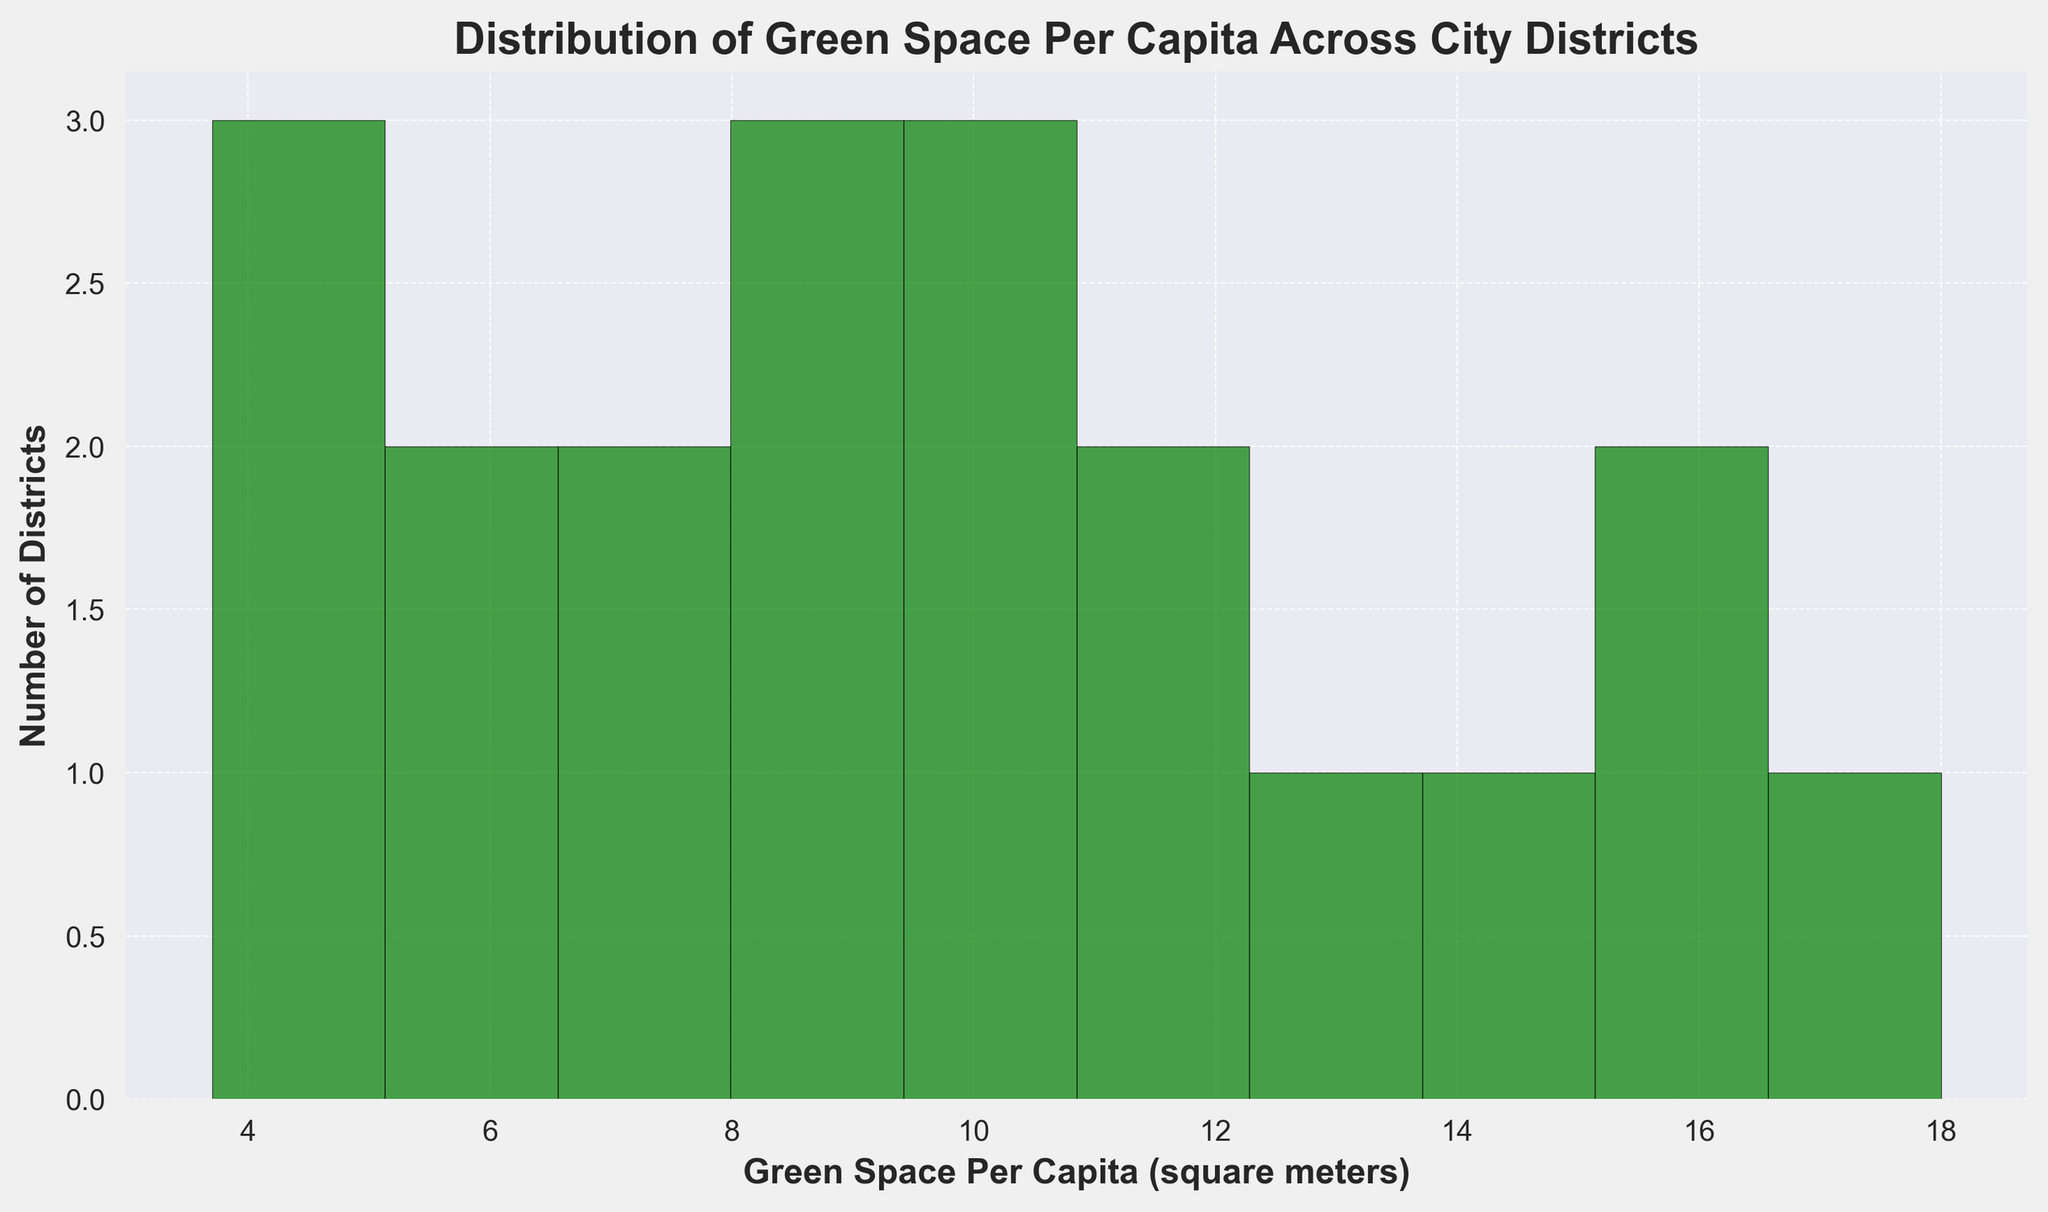Which green space per capita range has the highest number of districts? In the histogram, the green space per capita range represented by the tallest bar shows the highest number of districts.
Answer: 5-7 square meters Are there more districts with green space per capita less than 10 or more than 10? Count the number of districts with green space per capita on the left side of 10 (0-10) and on the right side of 10 (10-20) in the histogram. There are more bars to the right.
Answer: More than 10 What is the total number of districts represented in the histogram? By summing the heights of all bars in the histogram, you can determine the total number of districts.
Answer: 20 Compare the number of districts with green space per capita between 3 and 6 square meters to those between 12 and 15 square meters. Which range has more districts? Count the bars that fall within 3-6 and 12-15 square meters ranges. The 3-6 range has more districts than the 12-15 range.
Answer: 3-6 square meters What's the average green space per capita for districts with more than 10 square meters? Identify the bars with midpoints greater than 10, sum their midpoints, then divide by the number of such bars. (12+14+16+18)/4 = 15
Answer: 15 What's the ratio of the number of districts in the 8-10 range to those in the 4-6 range? Count the districts in both ranges. The counts for 8-10 and 4-6 are 5 and 3, respectively. The ratio is 5/3.
Answer: 5:3 How many districts have green space per capita between 6 and 10 square meters? Count the bars that fall within the 6-10 square meters range. The histogram shows 3 bars within this range.
Answer: 3 